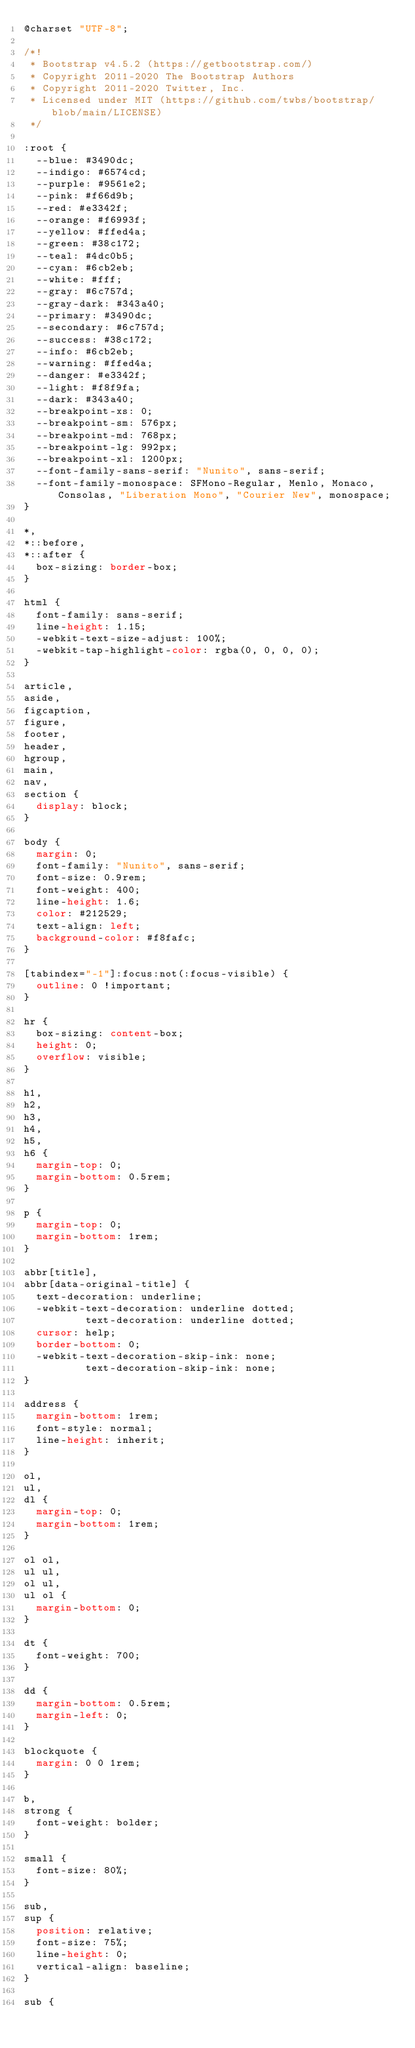<code> <loc_0><loc_0><loc_500><loc_500><_CSS_>@charset "UTF-8";

/*!
 * Bootstrap v4.5.2 (https://getbootstrap.com/)
 * Copyright 2011-2020 The Bootstrap Authors
 * Copyright 2011-2020 Twitter, Inc.
 * Licensed under MIT (https://github.com/twbs/bootstrap/blob/main/LICENSE)
 */

:root {
  --blue: #3490dc;
  --indigo: #6574cd;
  --purple: #9561e2;
  --pink: #f66d9b;
  --red: #e3342f;
  --orange: #f6993f;
  --yellow: #ffed4a;
  --green: #38c172;
  --teal: #4dc0b5;
  --cyan: #6cb2eb;
  --white: #fff;
  --gray: #6c757d;
  --gray-dark: #343a40;
  --primary: #3490dc;
  --secondary: #6c757d;
  --success: #38c172;
  --info: #6cb2eb;
  --warning: #ffed4a;
  --danger: #e3342f;
  --light: #f8f9fa;
  --dark: #343a40;
  --breakpoint-xs: 0;
  --breakpoint-sm: 576px;
  --breakpoint-md: 768px;
  --breakpoint-lg: 992px;
  --breakpoint-xl: 1200px;
  --font-family-sans-serif: "Nunito", sans-serif;
  --font-family-monospace: SFMono-Regular, Menlo, Monaco, Consolas, "Liberation Mono", "Courier New", monospace;
}

*,
*::before,
*::after {
  box-sizing: border-box;
}

html {
  font-family: sans-serif;
  line-height: 1.15;
  -webkit-text-size-adjust: 100%;
  -webkit-tap-highlight-color: rgba(0, 0, 0, 0);
}

article,
aside,
figcaption,
figure,
footer,
header,
hgroup,
main,
nav,
section {
  display: block;
}

body {
  margin: 0;
  font-family: "Nunito", sans-serif;
  font-size: 0.9rem;
  font-weight: 400;
  line-height: 1.6;
  color: #212529;
  text-align: left;
  background-color: #f8fafc;
}

[tabindex="-1"]:focus:not(:focus-visible) {
  outline: 0 !important;
}

hr {
  box-sizing: content-box;
  height: 0;
  overflow: visible;
}

h1,
h2,
h3,
h4,
h5,
h6 {
  margin-top: 0;
  margin-bottom: 0.5rem;
}

p {
  margin-top: 0;
  margin-bottom: 1rem;
}

abbr[title],
abbr[data-original-title] {
  text-decoration: underline;
  -webkit-text-decoration: underline dotted;
          text-decoration: underline dotted;
  cursor: help;
  border-bottom: 0;
  -webkit-text-decoration-skip-ink: none;
          text-decoration-skip-ink: none;
}

address {
  margin-bottom: 1rem;
  font-style: normal;
  line-height: inherit;
}

ol,
ul,
dl {
  margin-top: 0;
  margin-bottom: 1rem;
}

ol ol,
ul ul,
ol ul,
ul ol {
  margin-bottom: 0;
}

dt {
  font-weight: 700;
}

dd {
  margin-bottom: 0.5rem;
  margin-left: 0;
}

blockquote {
  margin: 0 0 1rem;
}

b,
strong {
  font-weight: bolder;
}

small {
  font-size: 80%;
}

sub,
sup {
  position: relative;
  font-size: 75%;
  line-height: 0;
  vertical-align: baseline;
}

sub {</code> 